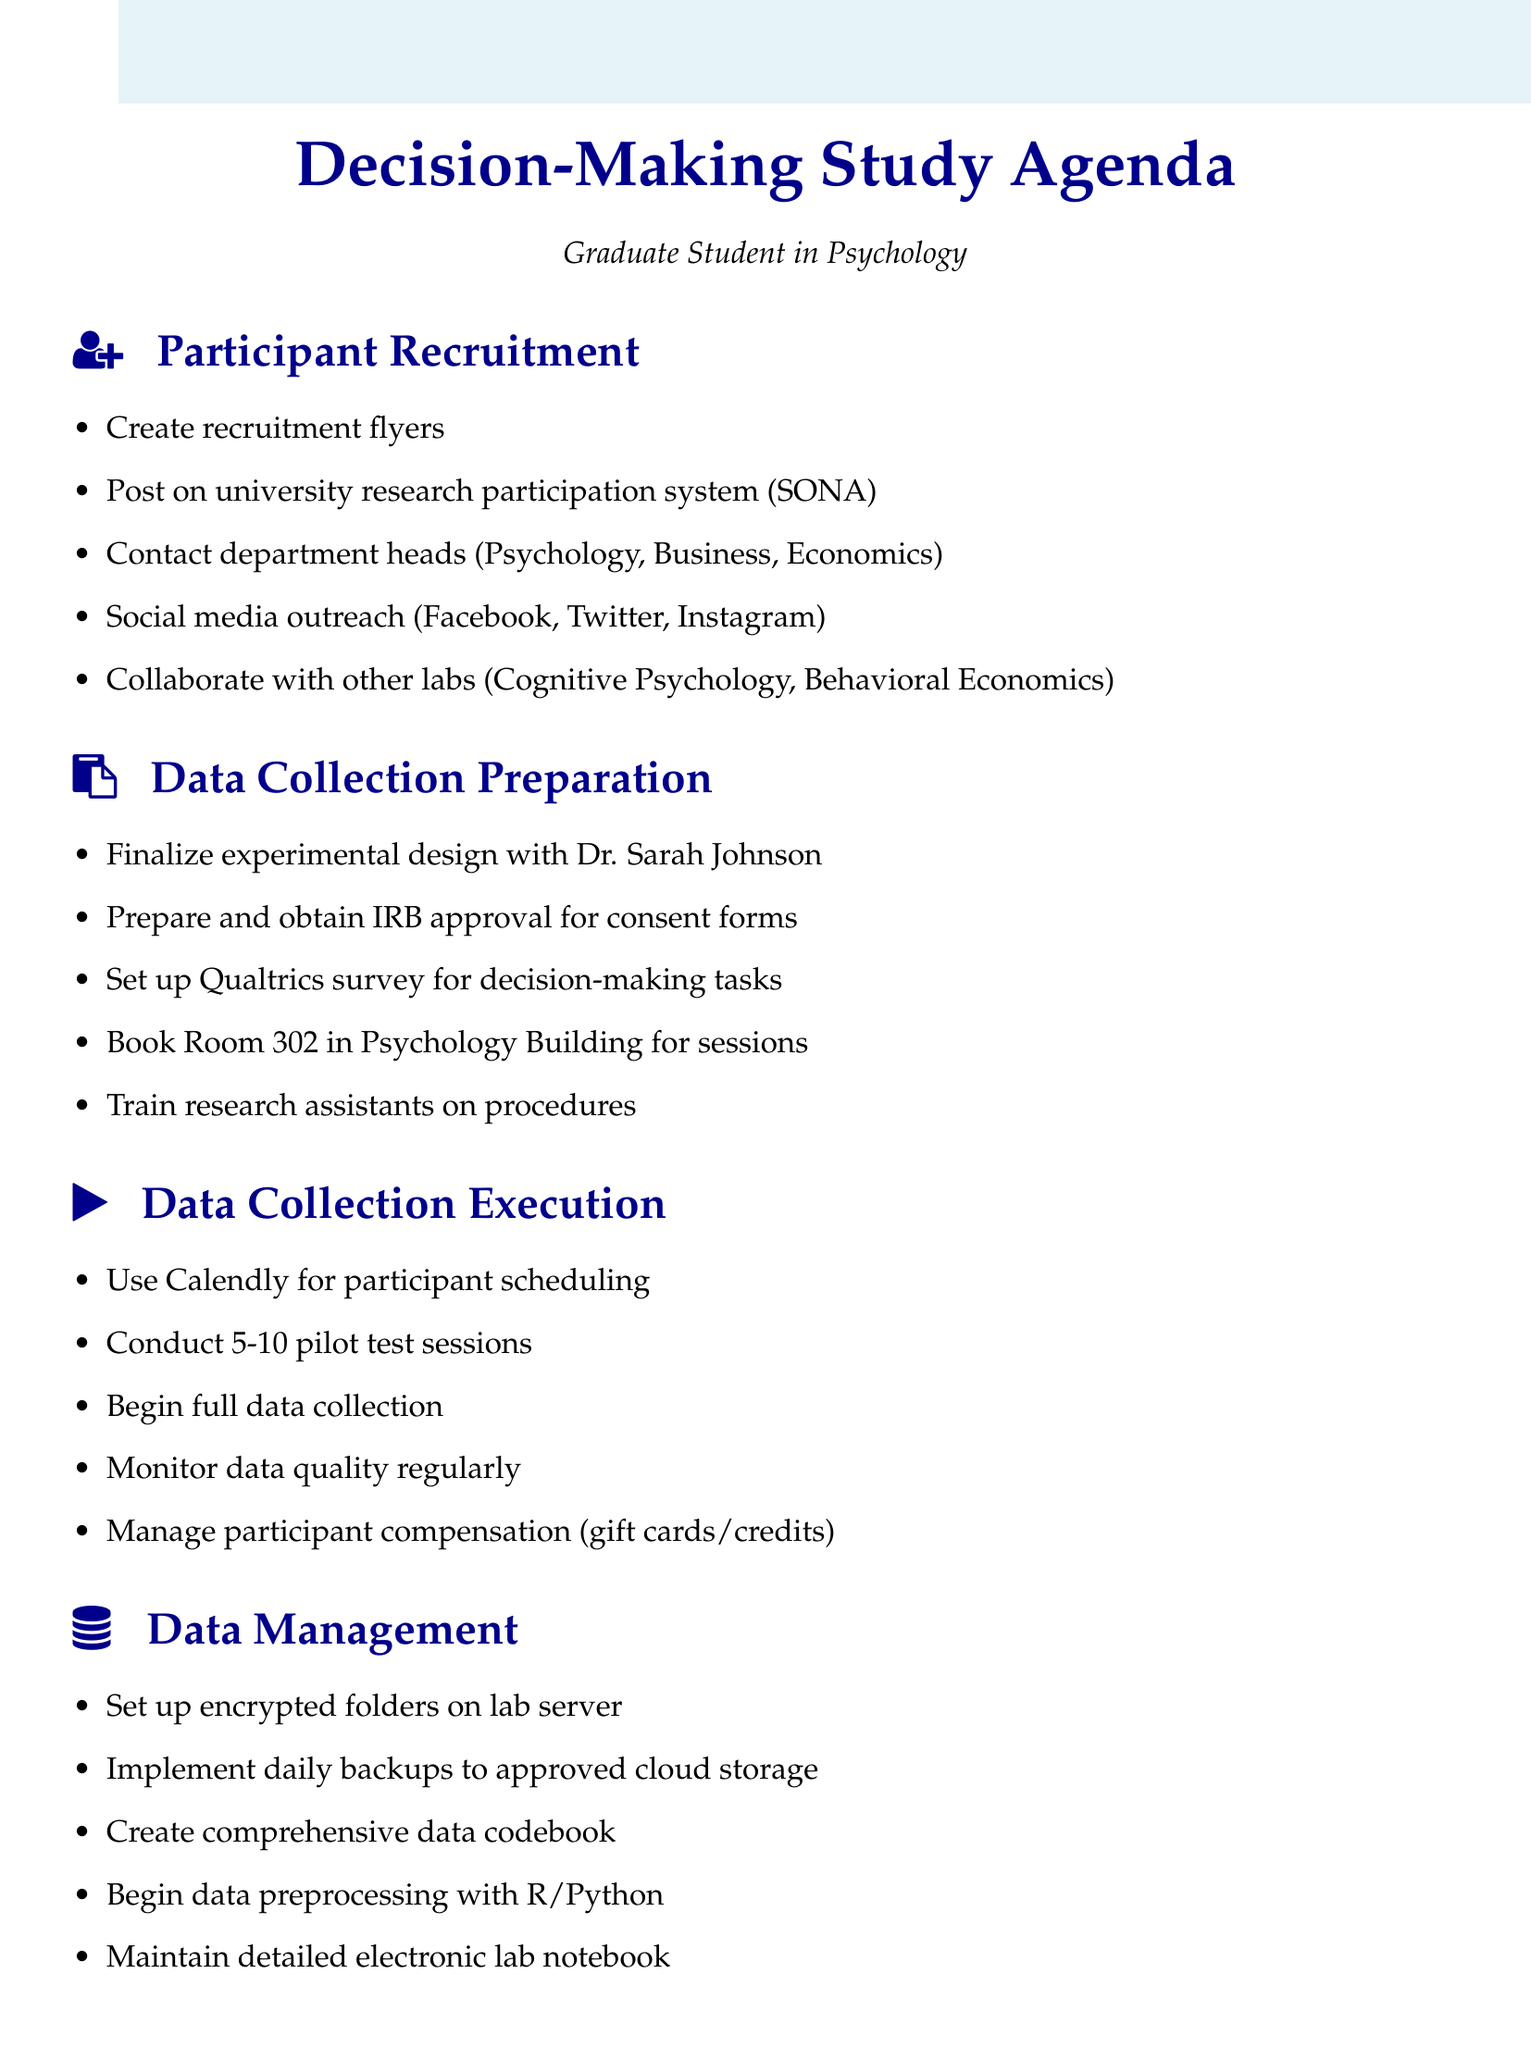What is the first task in participant recruitment? The first task listed under participant recruitment is "Create recruitment flyers."
Answer: Create recruitment flyers Who needs to review the experimental design? The document specifies that the experimental design needs review by Dr. Sarah Johnson.
Answer: Dr. Sarah Johnson What tool will be used for scheduling participants? The document mentions that Calendly will be used to manage participant sign-ups.
Answer: Calendly How many pilot testing sessions are planned? The agenda specifies conducting 5-10 pilot sessions for testing.
Answer: 5-10 What type of compensation will participants receive? The document states that participants will receive either Amazon gift cards or course credits.
Answer: Amazon gift cards or course credits What is the purpose of creating a comprehensive data codebook? The codebook is intended to explain all variables and coding schemes in the study.
Answer: Explain all variables and coding schemes What space is reserved for in-person data collection sessions? The agenda indicates that Room 302 in the Psychology Building is booked for sessions.
Answer: Room 302 What is the last task mentioned in data management? The last task under data management is to maintain a detailed electronic lab notebook.
Answer: Maintain detailed electronic lab notebook 